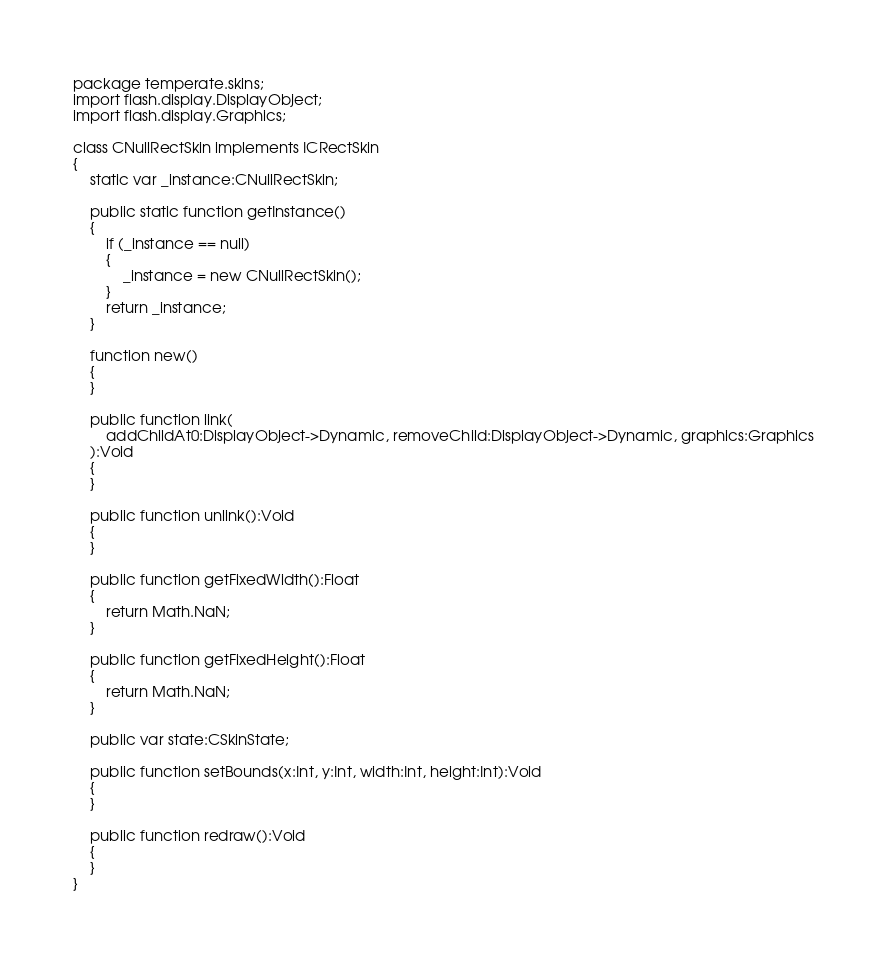Convert code to text. <code><loc_0><loc_0><loc_500><loc_500><_Haxe_>package temperate.skins;
import flash.display.DisplayObject;
import flash.display.Graphics;

class CNullRectSkin implements ICRectSkin
{
	static var _instance:CNullRectSkin;
	
	public static function getInstance()
	{
		if (_instance == null)
		{
			_instance = new CNullRectSkin();
		}
		return _instance;
	}
	
	function new() 
	{
	}
	
	public function link(
		addChildAt0:DisplayObject->Dynamic, removeChild:DisplayObject->Dynamic, graphics:Graphics
	):Void
	{
	}
	
	public function unlink():Void
	{
	}
	
	public function getFixedWidth():Float
	{
		return Math.NaN;
	}
	
	public function getFixedHeight():Float
	{
		return Math.NaN;
	}
	
	public var state:CSkinState;
	
	public function setBounds(x:Int, y:Int, width:Int, height:Int):Void
	{
	}
	
	public function redraw():Void
	{
	}
}</code> 